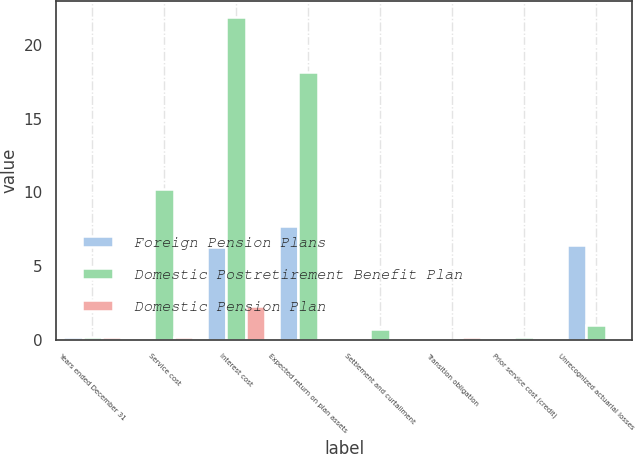<chart> <loc_0><loc_0><loc_500><loc_500><stacked_bar_chart><ecel><fcel>Years ended December 31<fcel>Service cost<fcel>Interest cost<fcel>Expected return on plan assets<fcel>Settlement and curtailment<fcel>Transition obligation<fcel>Prior service cost (credit)<fcel>Unrecognized actuarial losses<nl><fcel>Foreign Pension Plans<fcel>0.2<fcel>0<fcel>6.3<fcel>7.7<fcel>0<fcel>0<fcel>0<fcel>6.4<nl><fcel>Domestic Postretirement Benefit Plan<fcel>0.2<fcel>10.2<fcel>21.9<fcel>18.2<fcel>0.7<fcel>0<fcel>0.2<fcel>1<nl><fcel>Domestic Pension Plan<fcel>0.2<fcel>0.2<fcel>2.3<fcel>0<fcel>0<fcel>0.2<fcel>0.1<fcel>0<nl></chart> 